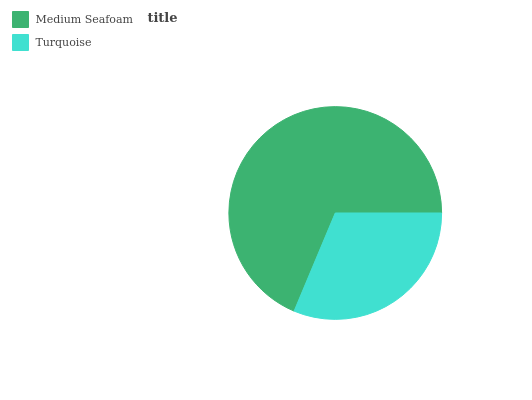Is Turquoise the minimum?
Answer yes or no. Yes. Is Medium Seafoam the maximum?
Answer yes or no. Yes. Is Turquoise the maximum?
Answer yes or no. No. Is Medium Seafoam greater than Turquoise?
Answer yes or no. Yes. Is Turquoise less than Medium Seafoam?
Answer yes or no. Yes. Is Turquoise greater than Medium Seafoam?
Answer yes or no. No. Is Medium Seafoam less than Turquoise?
Answer yes or no. No. Is Medium Seafoam the high median?
Answer yes or no. Yes. Is Turquoise the low median?
Answer yes or no. Yes. Is Turquoise the high median?
Answer yes or no. No. Is Medium Seafoam the low median?
Answer yes or no. No. 